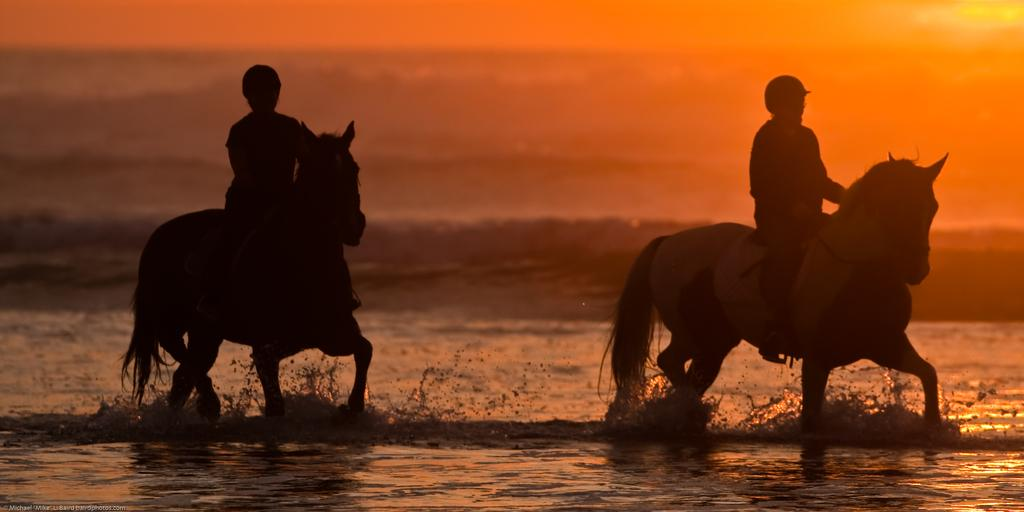What is the color scheme of the image? The image is black and white. What animals can be seen in the image? There are two horses in the image. What are the horses doing in the image? Two men are riding the horses. What can be seen in the sky at the top of the image? There is a sunset visible at the top of the image. Where is the shop located in the image? There is no shop present in the image. Can you tell me how many pigs are visible in the image? There are no pigs visible in the image; it features two horses and two men riding them. 